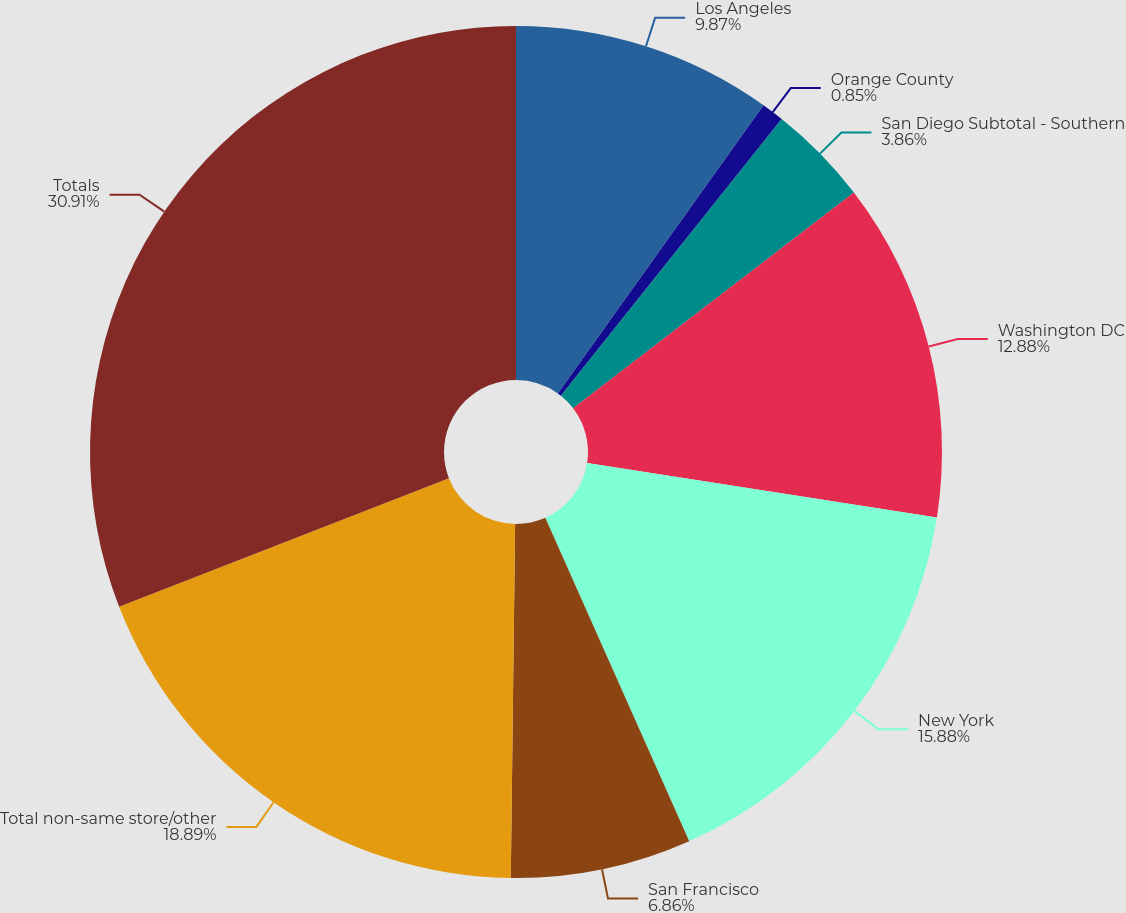Convert chart. <chart><loc_0><loc_0><loc_500><loc_500><pie_chart><fcel>Los Angeles<fcel>Orange County<fcel>San Diego Subtotal - Southern<fcel>Washington DC<fcel>New York<fcel>San Francisco<fcel>Total non-same store/other<fcel>Totals<nl><fcel>9.87%<fcel>0.85%<fcel>3.86%<fcel>12.88%<fcel>15.88%<fcel>6.86%<fcel>18.89%<fcel>30.92%<nl></chart> 